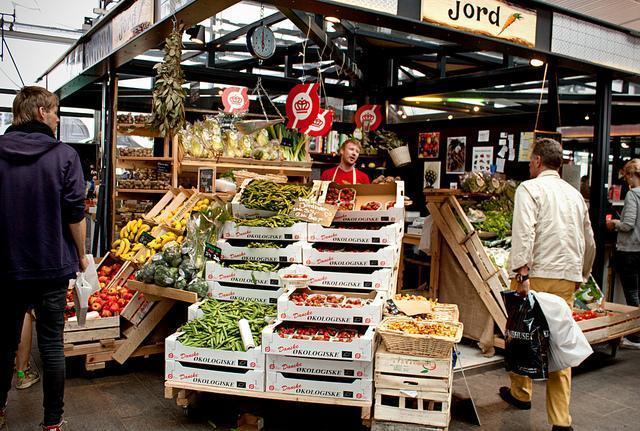How many people are there?
Give a very brief answer. 3. 